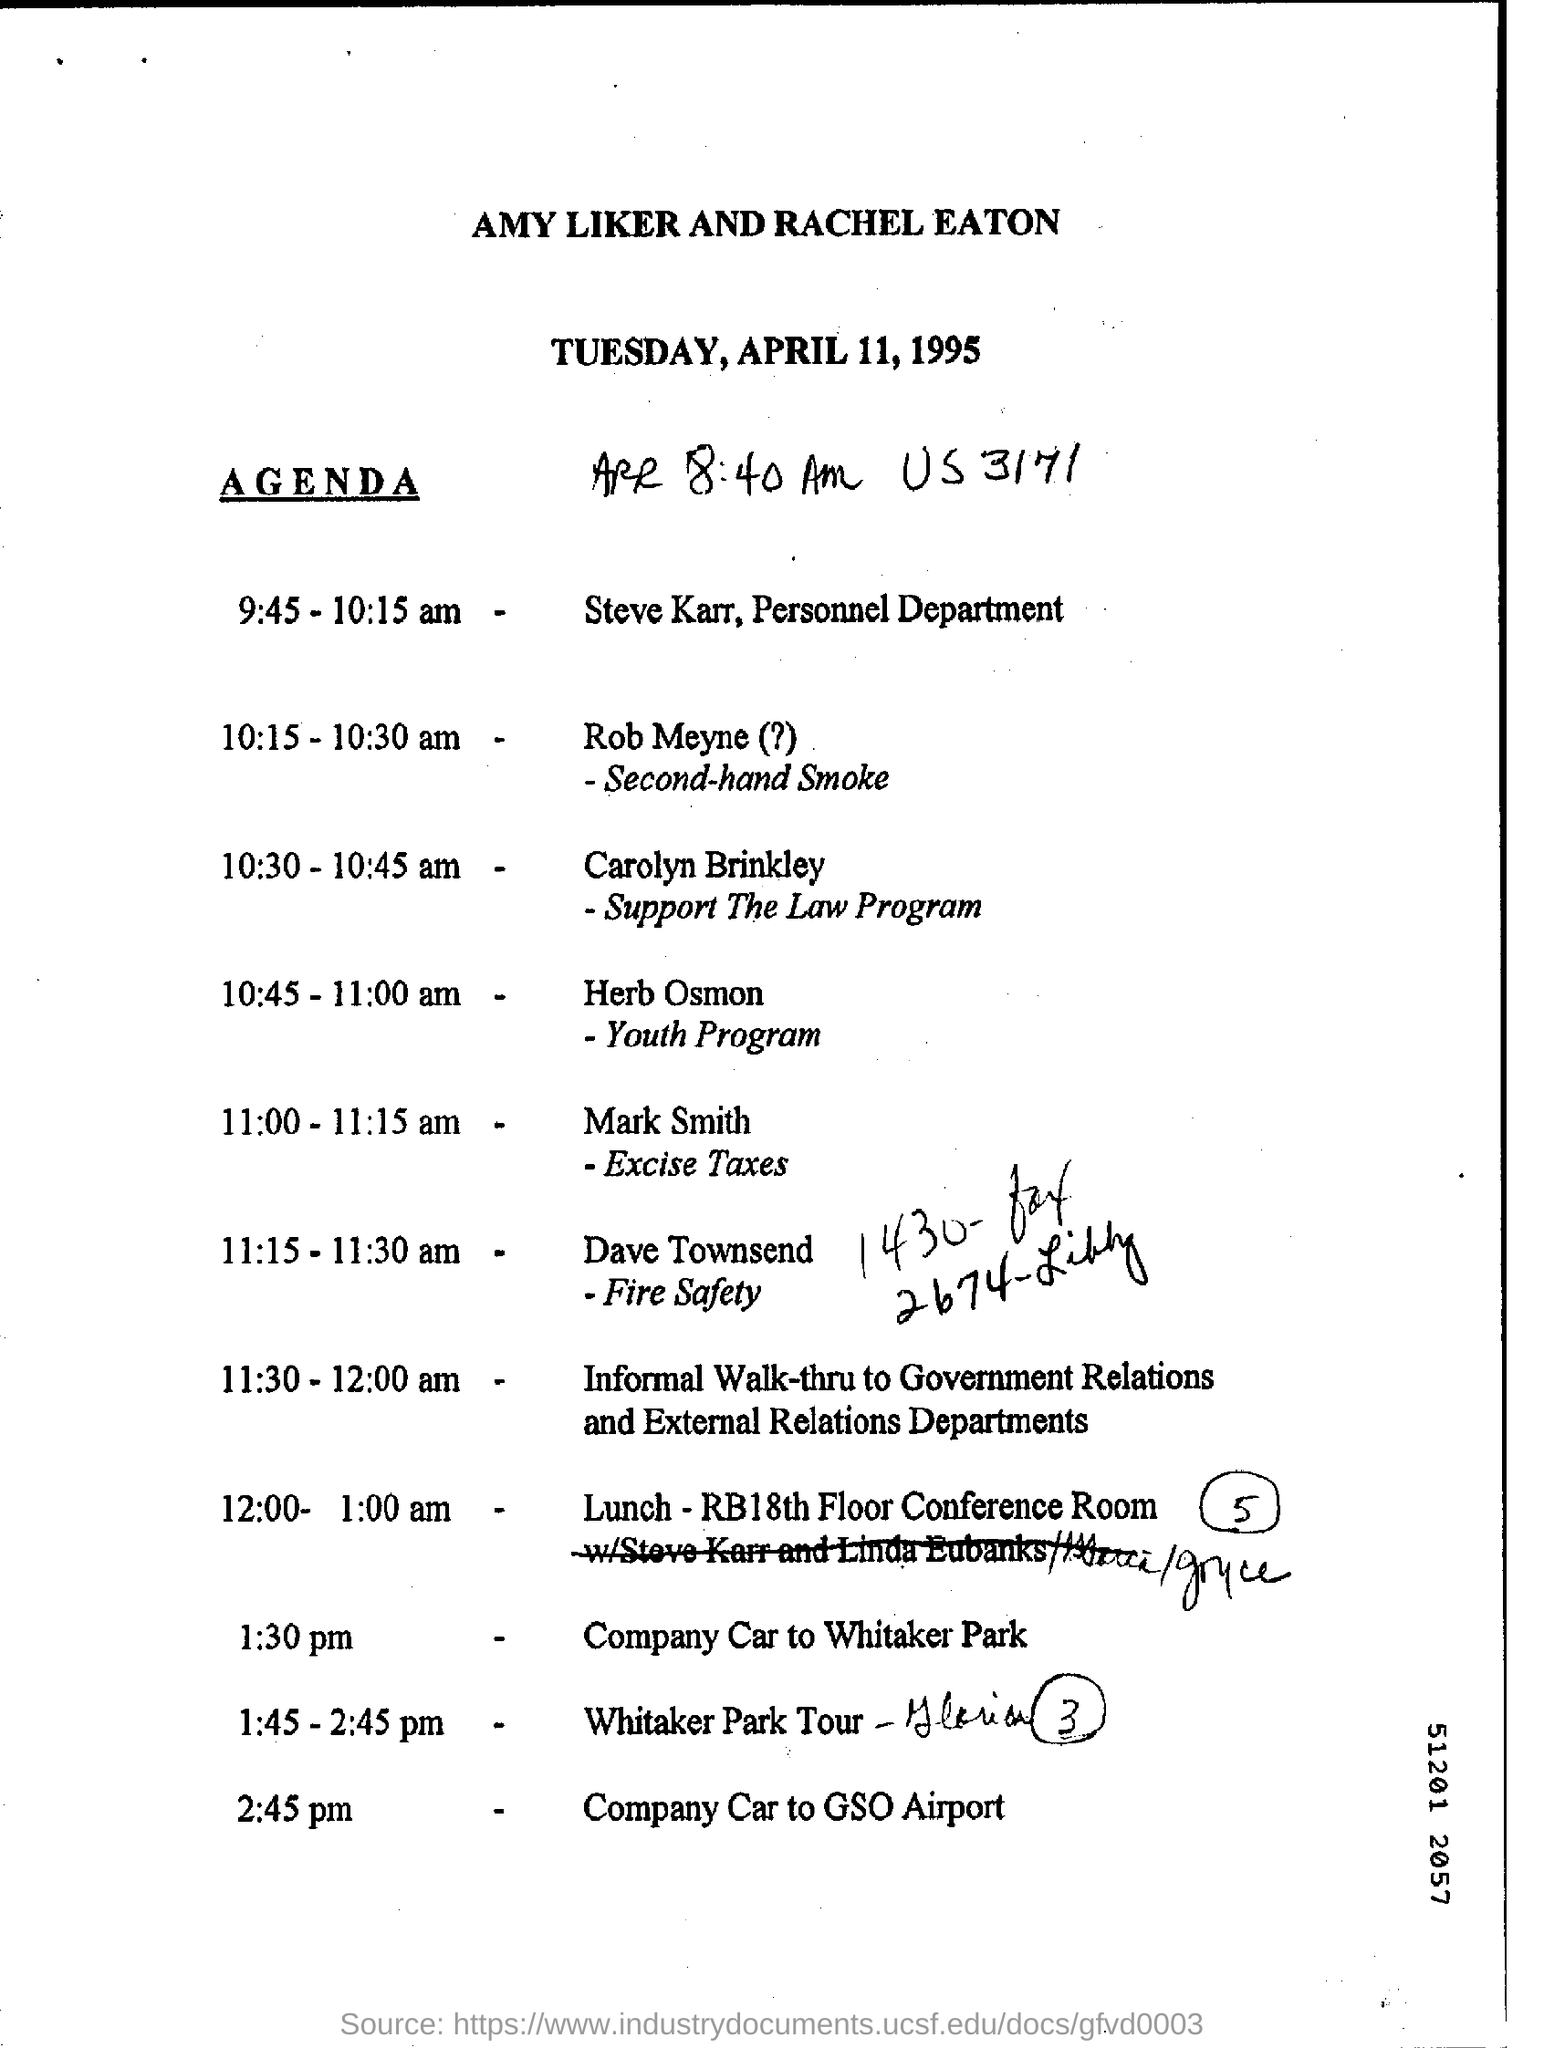Highlight a few significant elements in this photo. Who handles the Support The Law Program? That would be Carolyn Brinkley. The day mentioned in the header is Tuesday. Steve Karr is a member of the Personnel department. Dave Townsend handles the topic of fire safety. The lunch will be arranged on the 18th floor conference room according to the agenda. 